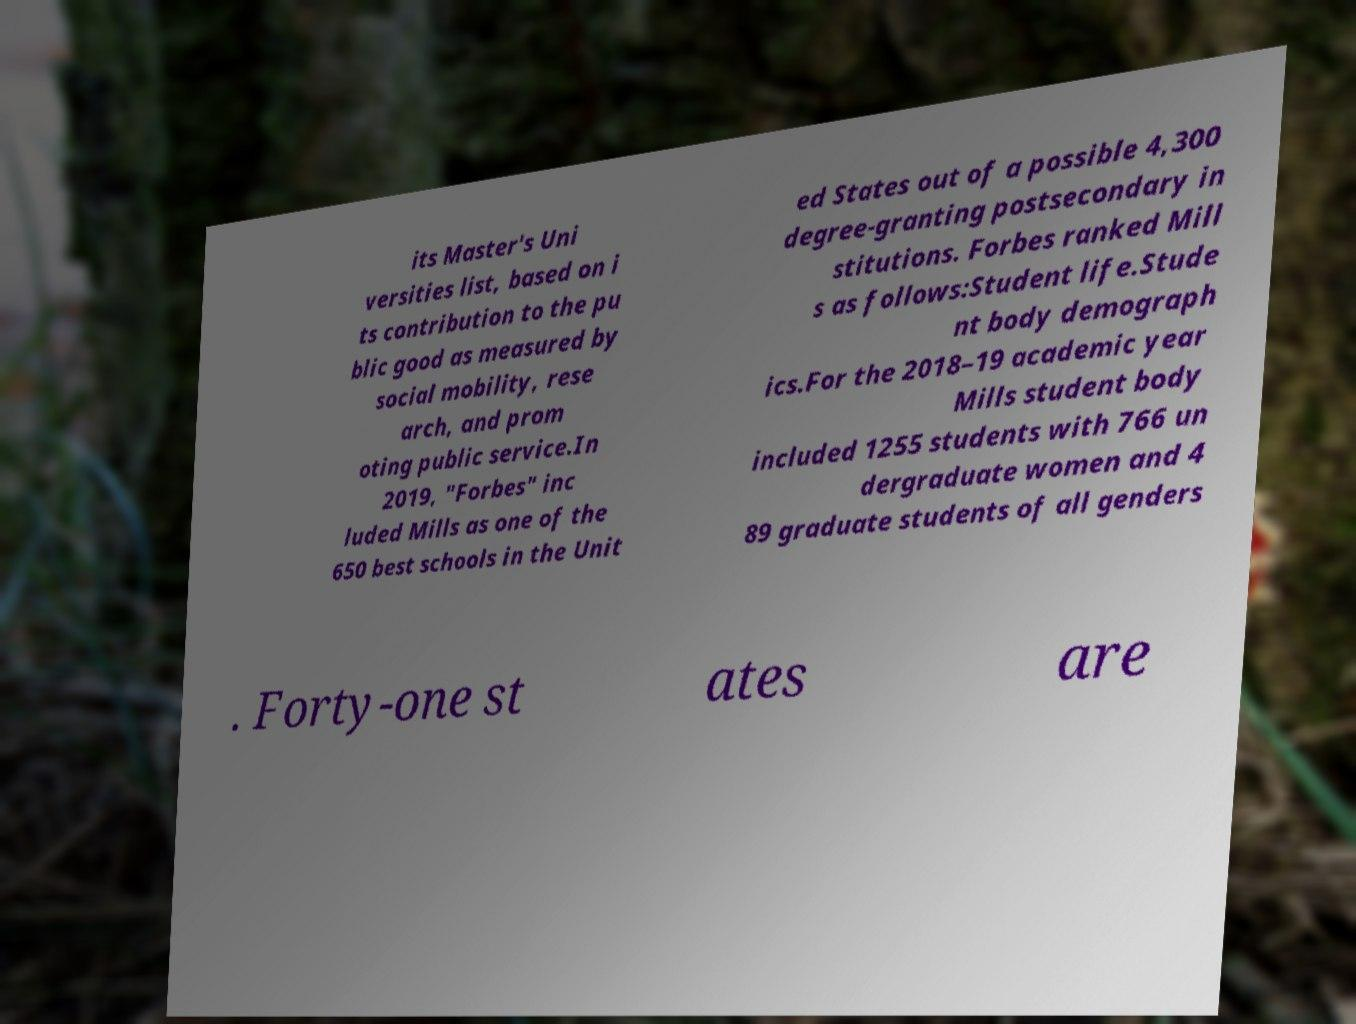There's text embedded in this image that I need extracted. Can you transcribe it verbatim? its Master's Uni versities list, based on i ts contribution to the pu blic good as measured by social mobility, rese arch, and prom oting public service.In 2019, "Forbes" inc luded Mills as one of the 650 best schools in the Unit ed States out of a possible 4,300 degree-granting postsecondary in stitutions. Forbes ranked Mill s as follows:Student life.Stude nt body demograph ics.For the 2018–19 academic year Mills student body included 1255 students with 766 un dergraduate women and 4 89 graduate students of all genders . Forty-one st ates are 